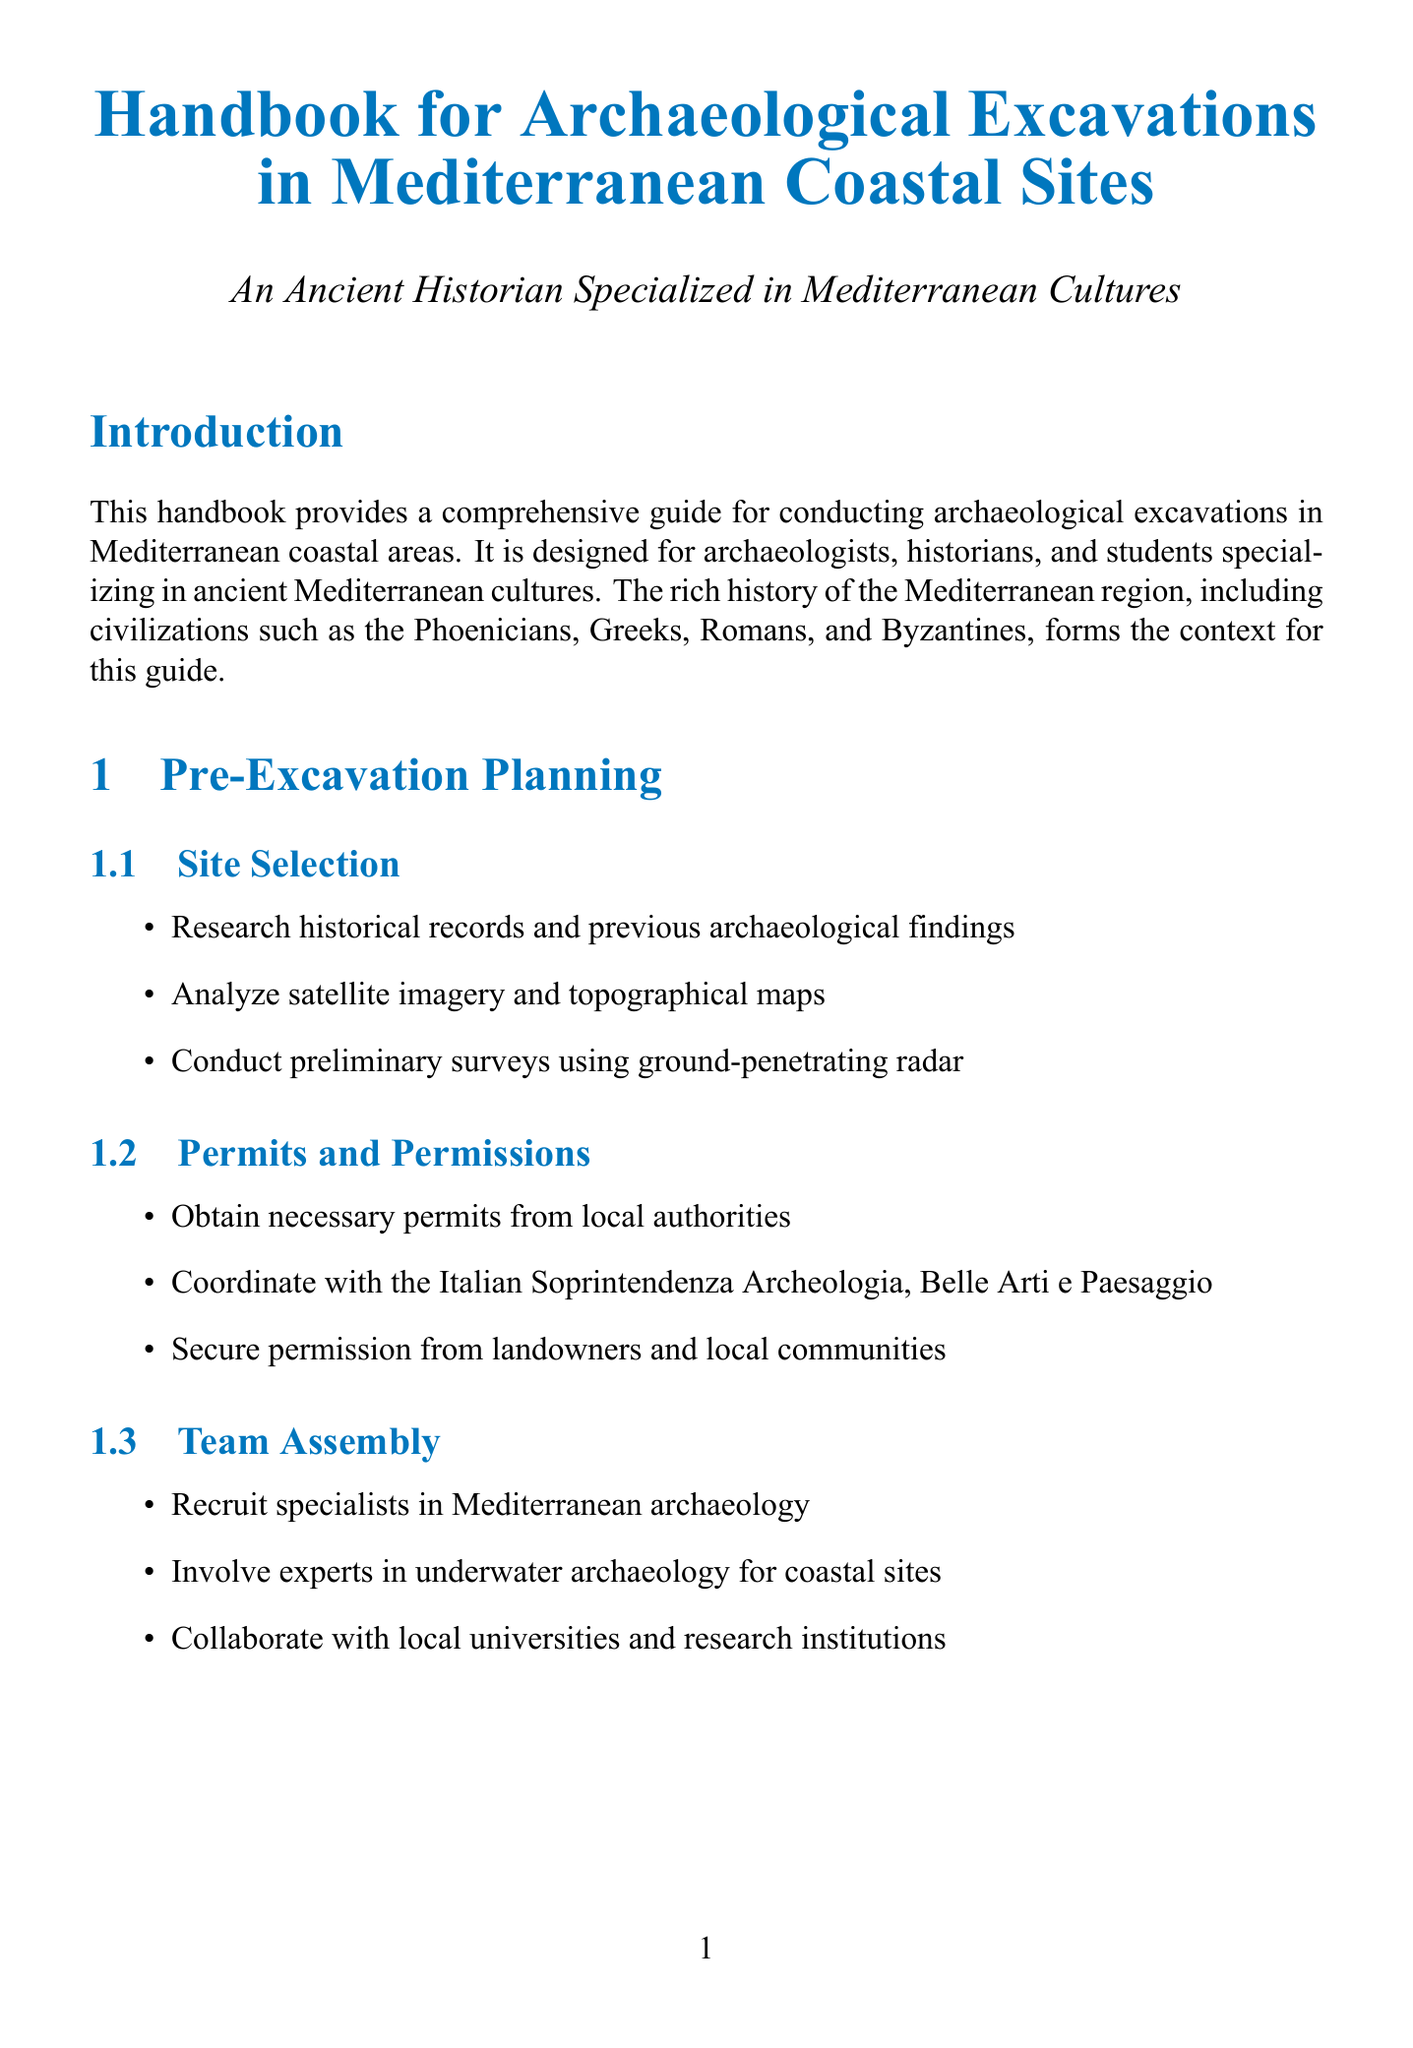What is the purpose of the handbook? The handbook aims to provide a comprehensive guide for conducting archaeological excavations in Mediterranean coastal areas.
Answer: Comprehensive guide for conducting archaeological excavations in Mediterranean coastal areas Who is the target audience? The target audience includes archaeologists, historians, and students specializing in ancient Mediterranean cultures.
Answer: Archaeologists, historians, and students specializing in ancient Mediterranean cultures What type of survey uses drone-based photogrammetry? The type of survey that employs drone-based photogrammetry is the aerial survey.
Answer: Aerial survey What is a method used for detecting buried structures? A method for detecting buried structures mentioned in the document is magnetometry.
Answer: Magnetometry Which case study site is located in Tunisia? The site located in Tunisia is Carthage.
Answer: Carthage What is the Harris Matrix used for? The Harris Matrix is created to visualize site formation processes in stratigraphic excavation.
Answer: To visualize site formation processes What essential document should excavation records be deposited with? Excavation records should be deposited with the Archaeology Data Service.
Answer: Archaeology Data Service What type of models can be created using Structure from Motion? 3D models of excavation progress can be created using Structure from Motion.
Answer: 3D models of excavation progress What is the condition maintained during artifact storage? The stable environmental conditions are maintained during artifact storage.
Answer: Stable environmental conditions 